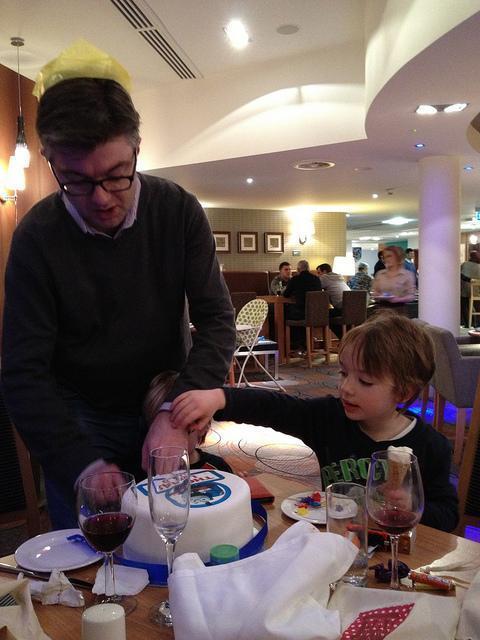How many people are there?
Give a very brief answer. 3. How many wine glasses are there?
Give a very brief answer. 3. How many chairs are there?
Give a very brief answer. 4. How many people are to the left of the motorcycles in this image?
Give a very brief answer. 0. 